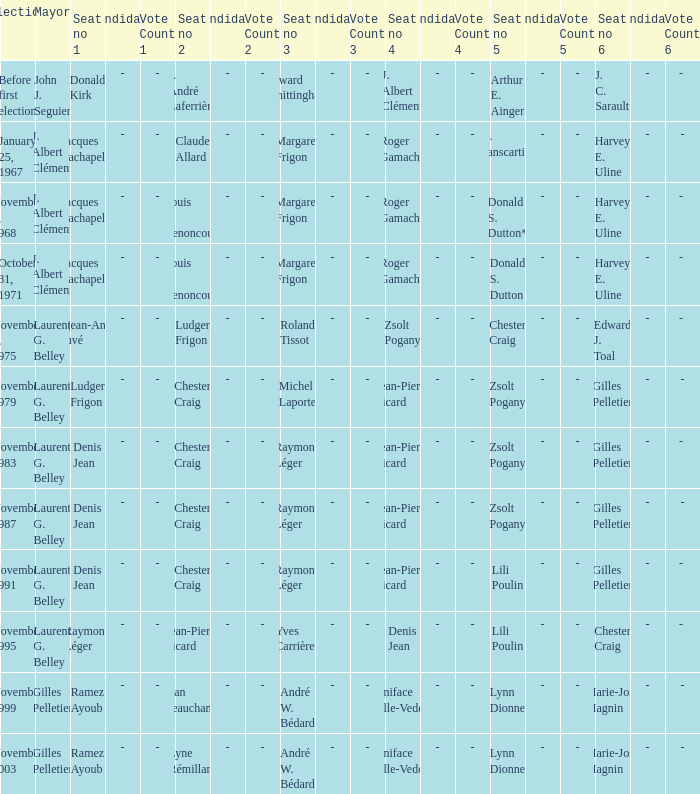Who was the victor of seat no 4 in the election held on january 25, 1967? Roger Gamache. 